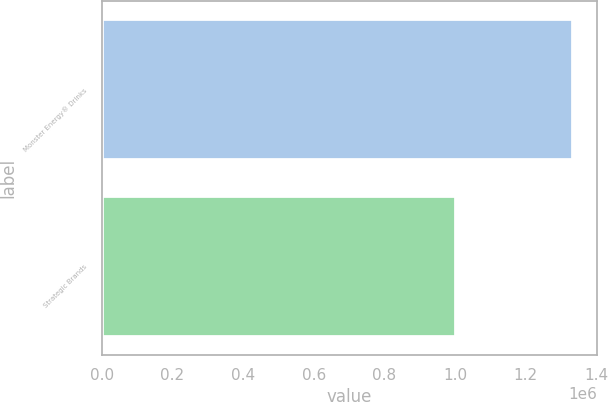<chart> <loc_0><loc_0><loc_500><loc_500><bar_chart><fcel>Monster Energy® Drinks<fcel>Strategic Brands<nl><fcel>1.33449e+06<fcel>1.00175e+06<nl></chart> 